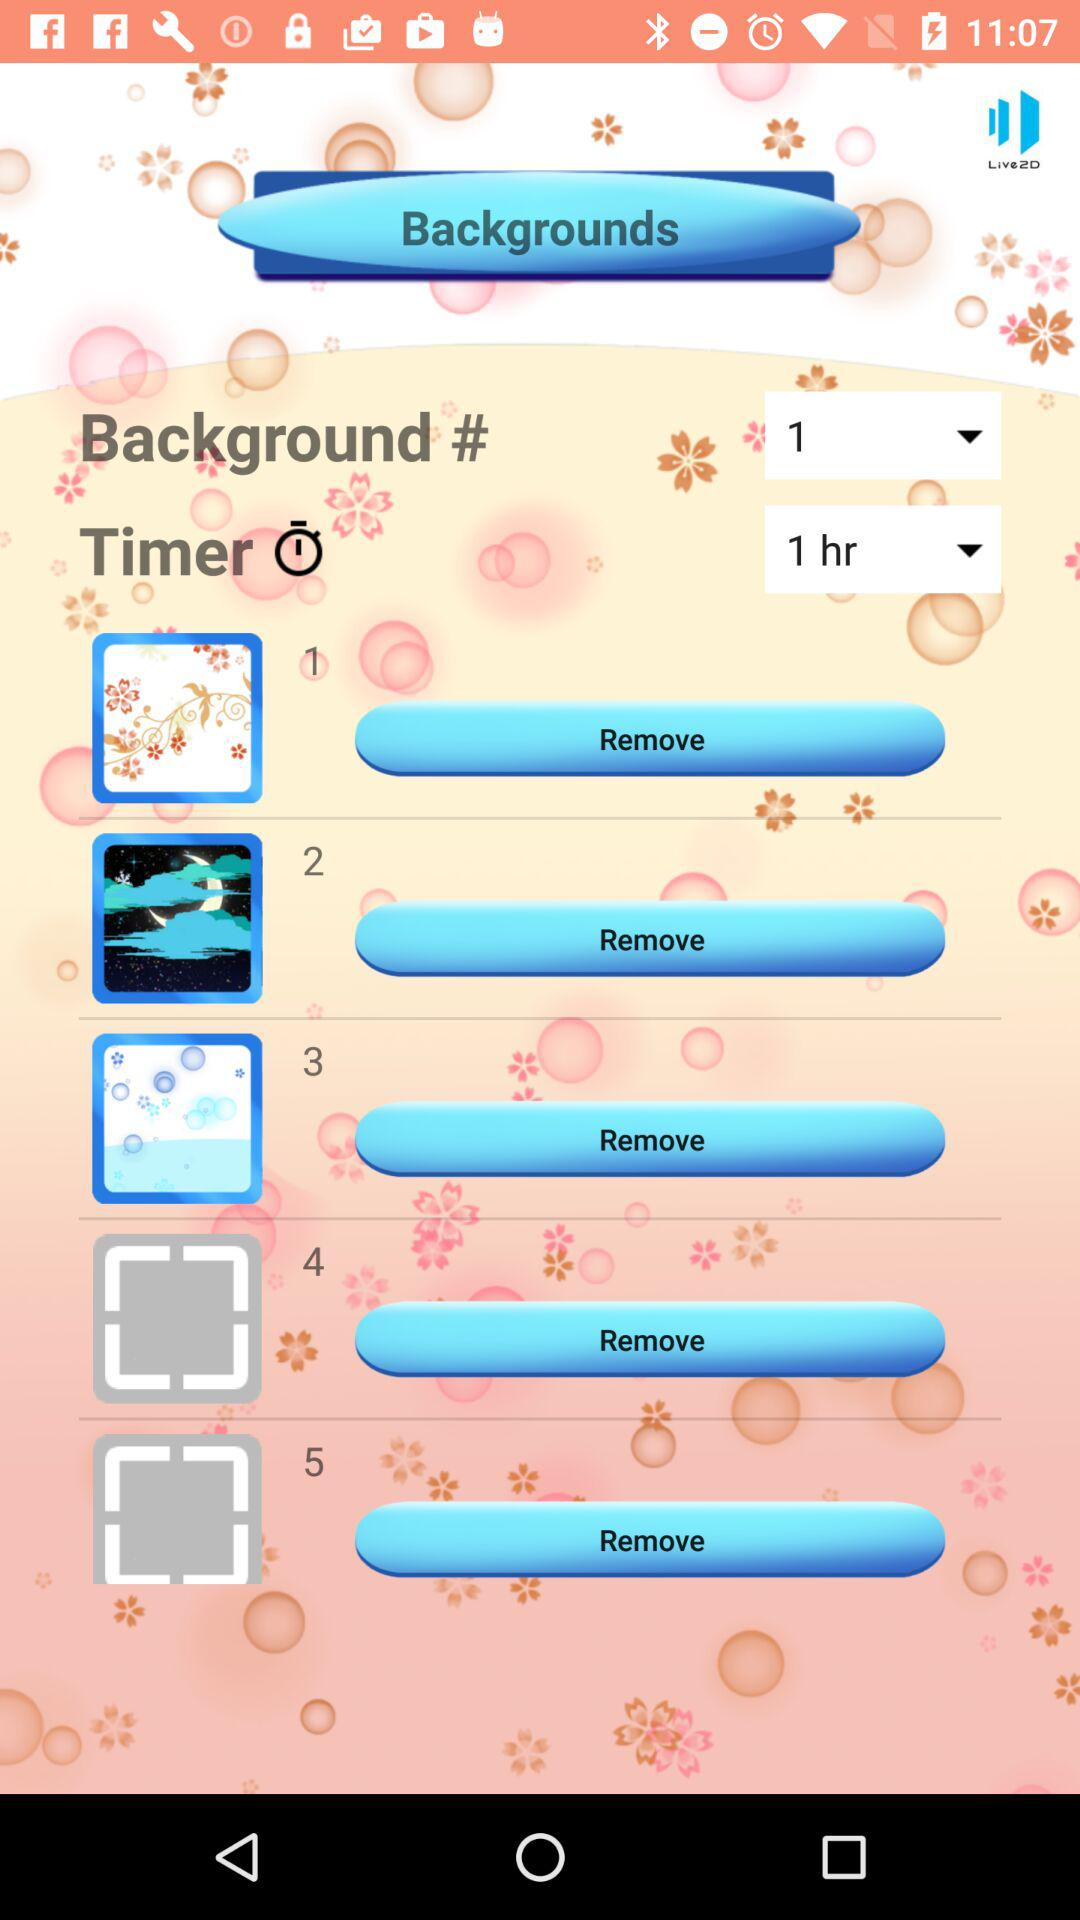What is the selected background? The selected background is 1. 